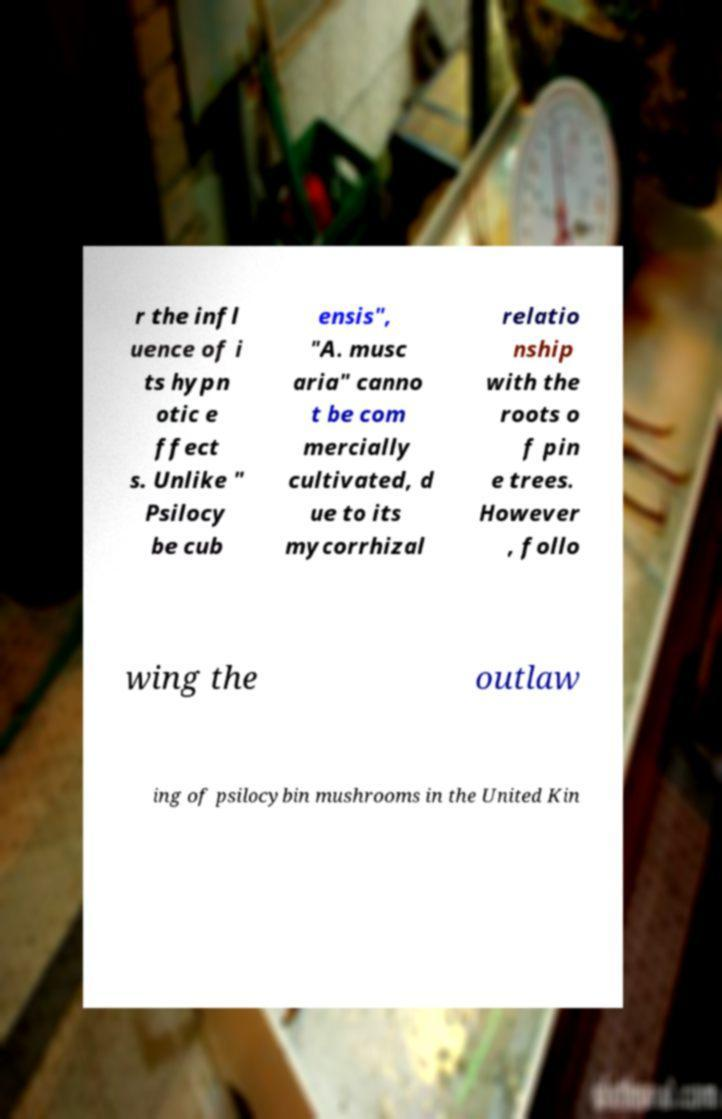Please read and relay the text visible in this image. What does it say? r the infl uence of i ts hypn otic e ffect s. Unlike " Psilocy be cub ensis", "A. musc aria" canno t be com mercially cultivated, d ue to its mycorrhizal relatio nship with the roots o f pin e trees. However , follo wing the outlaw ing of psilocybin mushrooms in the United Kin 